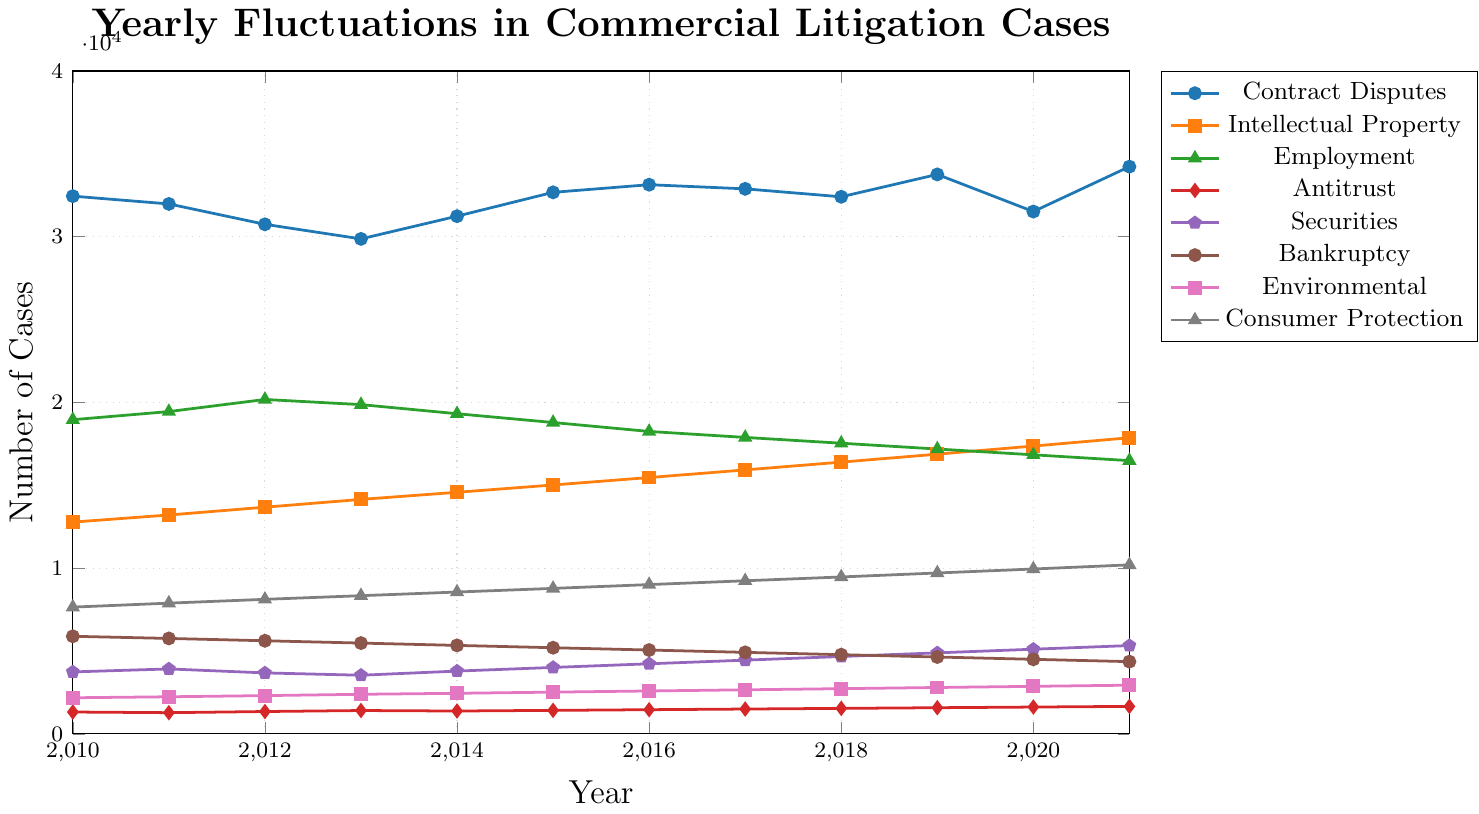How many Contract Disputes were filed in 2013, and how does this number compare to the filings in 2014? In 2013, Contract Disputes had 29,870 cases, and in 2014, it had 31,240 cases. The comparison shows that there was an increase in the filings. By calculating the difference: 31,240 - 29,870 = 1,370, we see an increase of 1,370 cases.
Answer: An increase of 1,370 cases Identify the category with the least number of cases filed in 2021. By looking at the 2021 data, we see:
- Contract Disputes: 34,230
- Intellectual Property: 17,870
- Employment: 16,490
- Antitrust: 1,660
- Securities: 5,330
- Bankruptcy: 4,360
- Environmental: 2,940
- Consumer Protection: 10,200
The Antitrust category has the least number of cases, with 1,660 filings.
Answer: Antitrust Which category shows a continuous increase in the number of cases filed from 2010 to 2021? We observe the trends of each category:
- Contract Disputes: fluctuates
- Intellectual Property: continuously increases
- Employment: mostly decreases
- Antitrust: continuously increases
- Securities: continuously increases
- Bankruptcy: decreases generally
- Environmental: continuously increases
- Consumer Protection: continuously increases
Both Intellectual Property, Antitrust, Securities, Environmental, and Consumer Protection show a continuous increase, but focusing on the query, Intellectual Property is a correct example.
Answer: Intellectual Property What is the average number of cases filed for Employment disputes from 2012 to 2016? From the years 2012 to 2016, the numbers for Employment disputes are: 20,180 (2012), 19,870 (2013), 19,320 (2014), 18,790 (2015), and 18,250 (2016). Calculate the average:
(20,180 + 19,870 + 19,320 + 18,790 + 18,250) / 5 = 96,410 / 5 = 19,282
Answer: 19,282 Compare the highest number of Consumer Protection cases filed in any year to the highest number of Contract Disputes cases filed in any year. The highest peaked year for Consumer Protection is 2021 with 10,200 cases. For Contract Disputes, it is 2021 with 34,230 cases. Comparing these two peaks: 34,230 (Contract Disputes) is higher than 10,200 (Consumer Protection).
Answer: Contract Disputes peak is higher In which year did the Environmental disputes cases reach 2,590, and how many more cases were there in this year compared to the previous year? Environmental cases reached 2,590 in 2016. In 2015, there were 2,520 cases. Calculating the difference: 2,590 - 2,520 = 70 more cases.
Answer: 2016, 70 more cases What trend can you observe in the number of Intellectual Property cases from 2015 to 2021? Observing the numbers: 15,020 (2015), 15,470 (2016), 15,930 (2017), 16,400 (2018), 16,880 (2019), 17,370 (2020), and 17,870 (2021), shows a consistent yearly increase in Intellectual Property cases from 2015 to 2021.
Answer: Consistent increase How does the number of Securities cases in 2020 compare to that in 2011, and what is the percentage increase? Securities cases in 2020 were 5,110, and in 2011, they were 3,920. The difference is 5,110 - 3,920 = 1,190. The percentage increase is: (1,190 / 3,920) × 100 ≈ 30.36%.
Answer: Approximately 30.36% increase What is the total number of cases filed for Antitrust disputes from 2010 to 2021? Summing the numbers for Antitrust from 2010 to 2021: 1,320 + 1,280 + 1,350 + 1,410 + 1,380 + 1,420 + 1,460 + 1,500 + 1,540 + 1,580 + 1,620 + 1,660 = 17,520
Answer: 17,520 